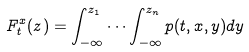<formula> <loc_0><loc_0><loc_500><loc_500>F ^ { x } _ { t } ( z ) = \int _ { - \infty } ^ { z _ { 1 } } \cdots \int _ { - \infty } ^ { z _ { n } } p ( t , x , y ) d y</formula> 